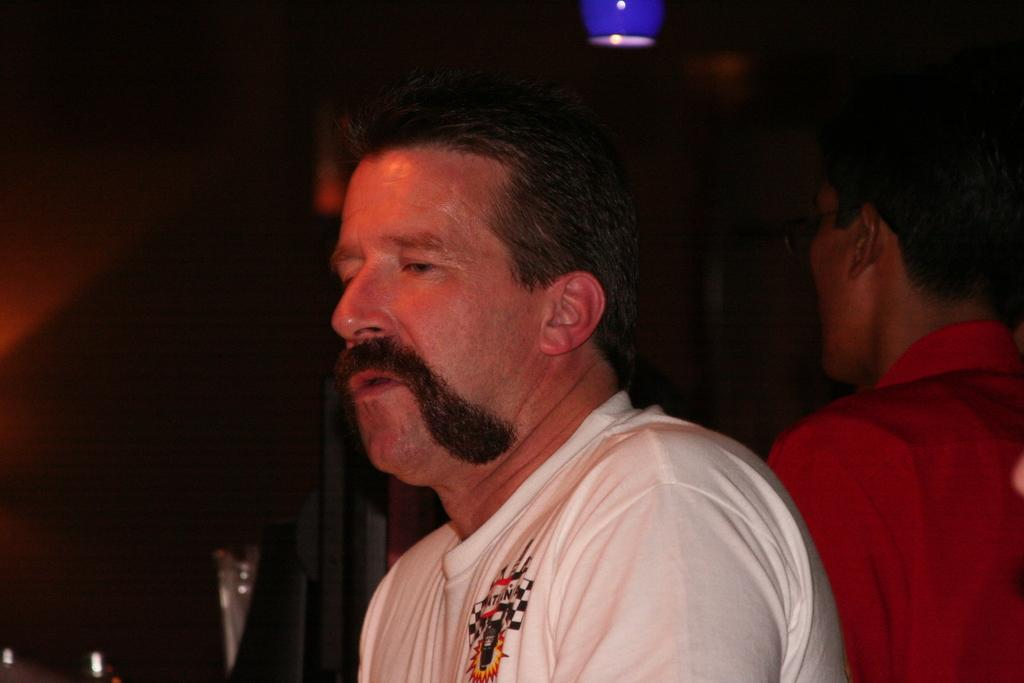How many people are in the image? There are two men in the image. What is hanging from the ceiling in the image? There is a ceiling lamp in the image. What type of object can be seen standing upright in the image? There is a metal pole in the image. What language are the men speaking in the image? The provided facts do not mention the language spoken by the men, so it cannot be determined from the image. 